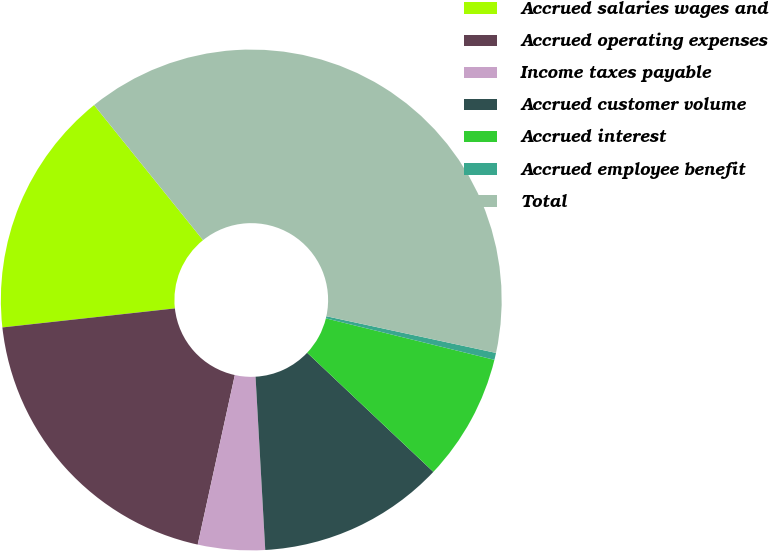<chart> <loc_0><loc_0><loc_500><loc_500><pie_chart><fcel>Accrued salaries wages and<fcel>Accrued operating expenses<fcel>Income taxes payable<fcel>Accrued customer volume<fcel>Accrued interest<fcel>Accrued employee benefit<fcel>Total<nl><fcel>15.95%<fcel>19.82%<fcel>4.32%<fcel>12.07%<fcel>8.2%<fcel>0.45%<fcel>39.19%<nl></chart> 